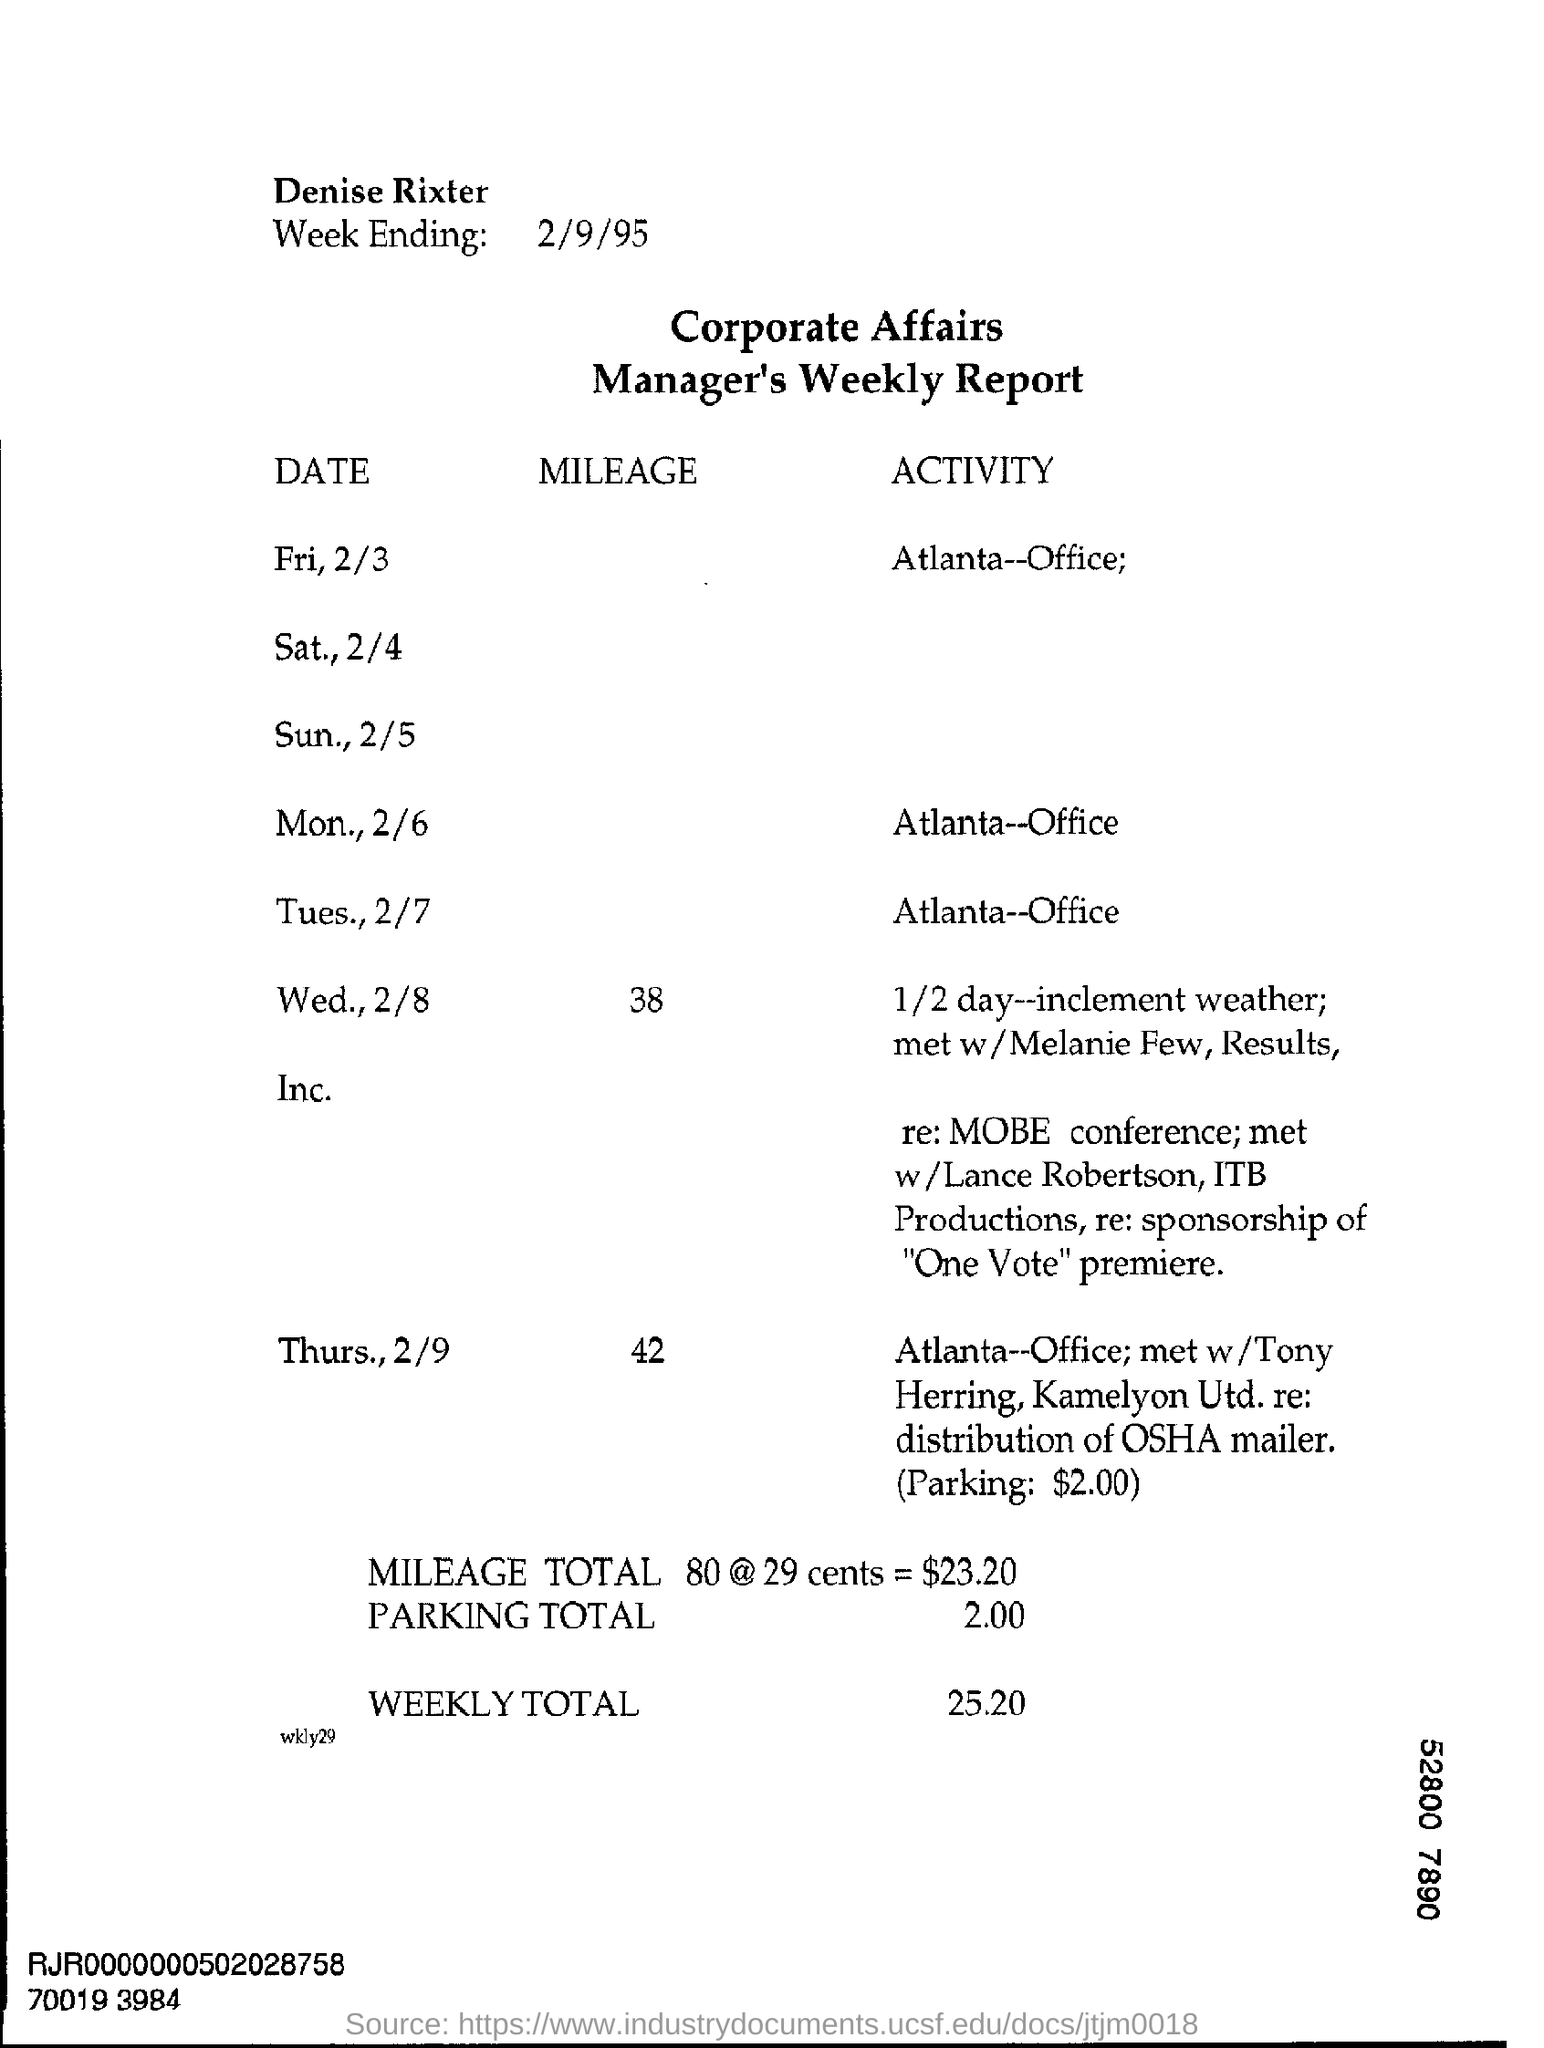Draw attention to some important aspects in this diagram. The week ending on February 9th, 1995 is asking for the date of that particular week. 